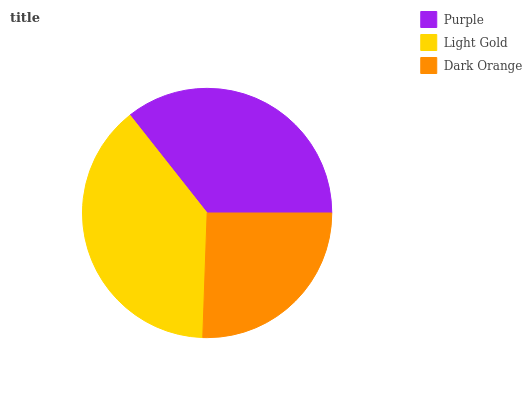Is Dark Orange the minimum?
Answer yes or no. Yes. Is Light Gold the maximum?
Answer yes or no. Yes. Is Light Gold the minimum?
Answer yes or no. No. Is Dark Orange the maximum?
Answer yes or no. No. Is Light Gold greater than Dark Orange?
Answer yes or no. Yes. Is Dark Orange less than Light Gold?
Answer yes or no. Yes. Is Dark Orange greater than Light Gold?
Answer yes or no. No. Is Light Gold less than Dark Orange?
Answer yes or no. No. Is Purple the high median?
Answer yes or no. Yes. Is Purple the low median?
Answer yes or no. Yes. Is Dark Orange the high median?
Answer yes or no. No. Is Light Gold the low median?
Answer yes or no. No. 